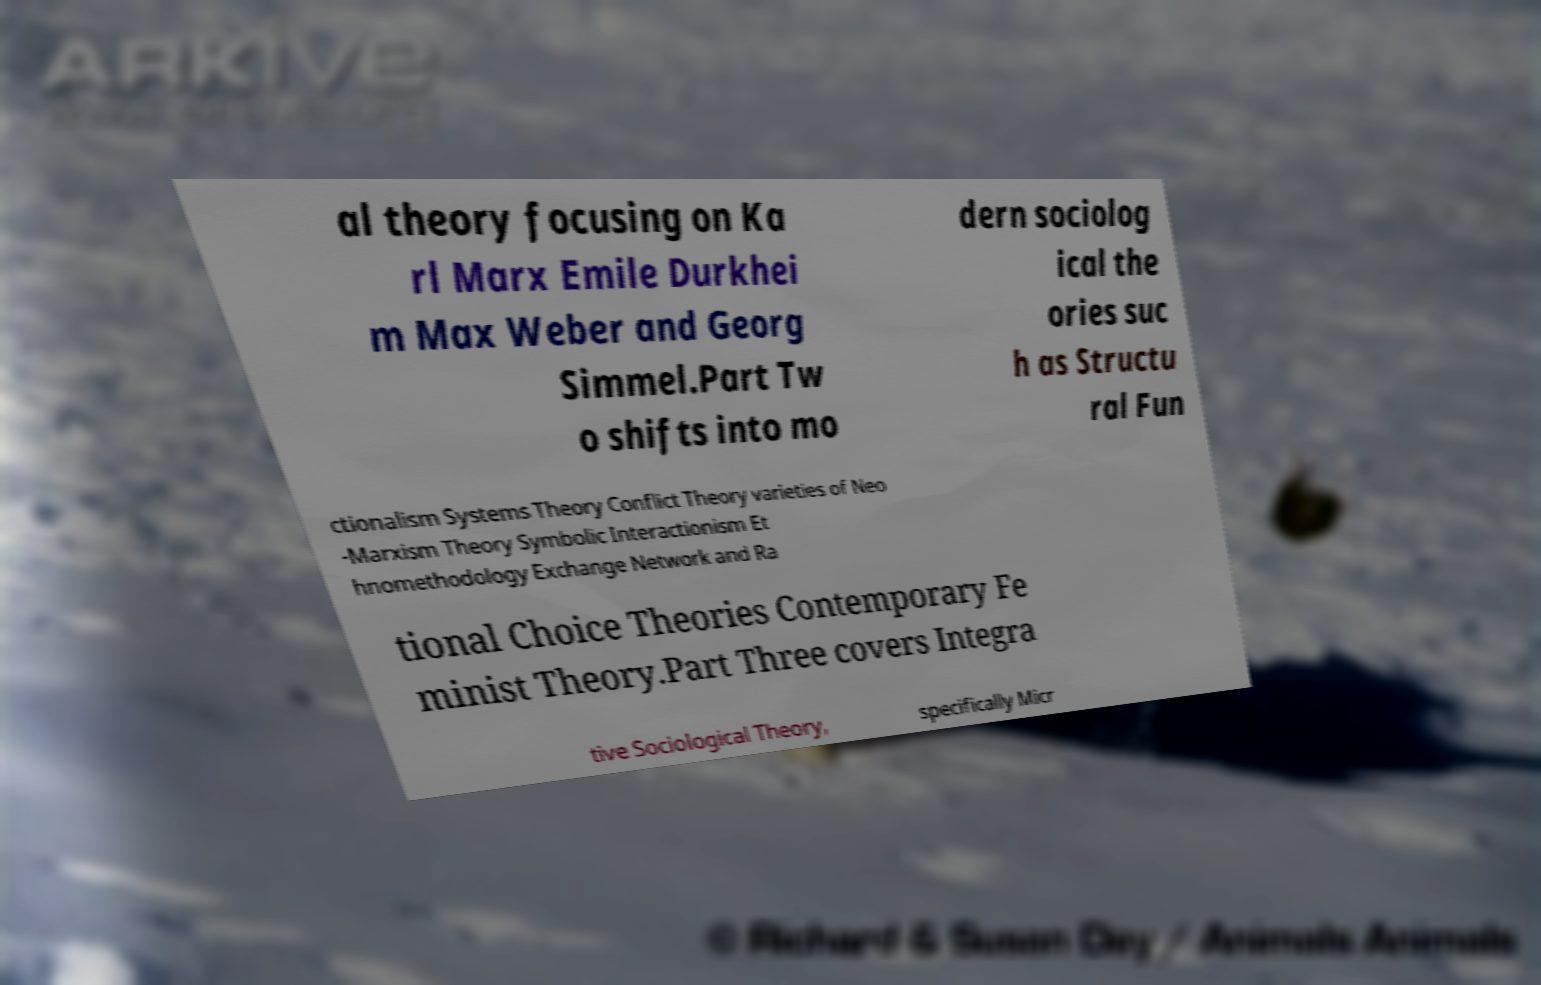Can you read and provide the text displayed in the image?This photo seems to have some interesting text. Can you extract and type it out for me? al theory focusing on Ka rl Marx Emile Durkhei m Max Weber and Georg Simmel.Part Tw o shifts into mo dern sociolog ical the ories suc h as Structu ral Fun ctionalism Systems Theory Conflict Theory varieties of Neo -Marxism Theory Symbolic Interactionism Et hnomethodology Exchange Network and Ra tional Choice Theories Contemporary Fe minist Theory.Part Three covers Integra tive Sociological Theory, specifically Micr 